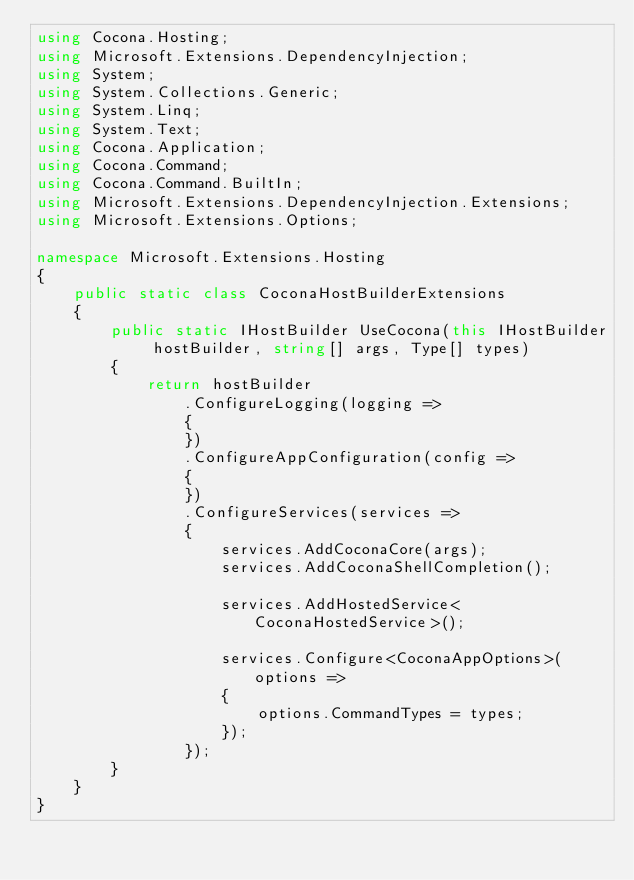<code> <loc_0><loc_0><loc_500><loc_500><_C#_>using Cocona.Hosting;
using Microsoft.Extensions.DependencyInjection;
using System;
using System.Collections.Generic;
using System.Linq;
using System.Text;
using Cocona.Application;
using Cocona.Command;
using Cocona.Command.BuiltIn;
using Microsoft.Extensions.DependencyInjection.Extensions;
using Microsoft.Extensions.Options;

namespace Microsoft.Extensions.Hosting
{
    public static class CoconaHostBuilderExtensions
    {
        public static IHostBuilder UseCocona(this IHostBuilder hostBuilder, string[] args, Type[] types)
        {
            return hostBuilder
                .ConfigureLogging(logging =>
                {
                })
                .ConfigureAppConfiguration(config =>
                {
                })
                .ConfigureServices(services =>
                {
                    services.AddCoconaCore(args);
                    services.AddCoconaShellCompletion();

                    services.AddHostedService<CoconaHostedService>();

                    services.Configure<CoconaAppOptions>(options =>
                    {
                        options.CommandTypes = types;
                    });
                });
        }
    }
}
</code> 